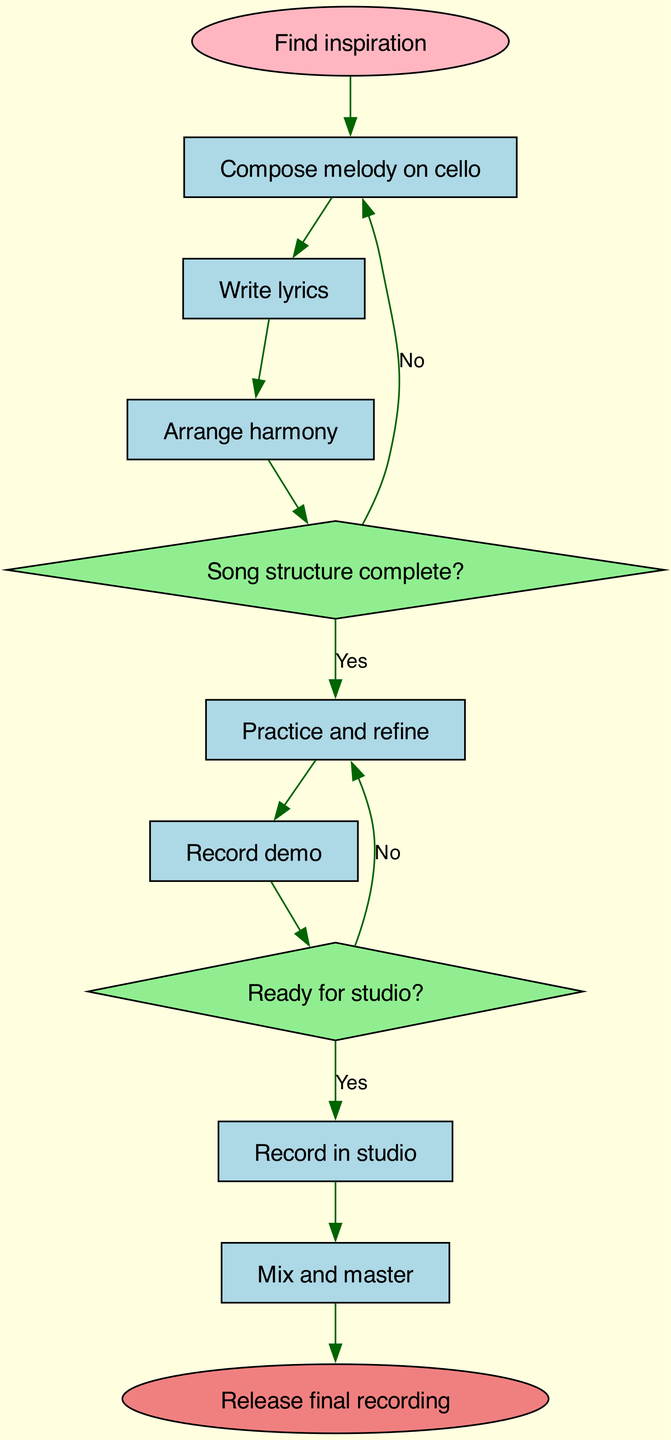What is the first step in the songwriting process? The diagram indicates that the first step is represented by the node labeled "Find inspiration." This is where the process begins, setting the foundation for all subsequent activities in songwriting.
Answer: Find inspiration How many decision points are there in the flowchart? In the diagram, there are two decision points, labeled "Song structure complete?" and "Ready for studio?" Each decision affects the flow of the process based on different criteria.
Answer: 2 What is the output of the final step in the process? The final step in the diagram is labeled "Release final recording." This marks the completion of the entire songwriting process, leading to the release of the finalized song.
Answer: Release final recording If the song structure is not complete, where does the flow lead? According to the diagram, if the song structure is not complete (indicated by the "No" path from the decision point), it leads back to "Compose melody on cello." This means the songwriter needs to revisit the melody creation step before progressing.
Answer: Compose melody on cello What happens after recording the demo? Following the "Record demo" step in the diagram, the next action indicated is "Ready for studio?" This decision point is crucial as it determines whether the process can move forward to the studio recording phase.
Answer: Ready for studio? What does the process require before recording in the studio? The diagram states that before recording in the studio, the song must be deemed "Ready for studio?". This step signifies that the songwriter needs to ensure their song is polished enough for professional recording.
Answer: Ready for studio? If the lyrics are written, what is the next step? Once the "Write lyrics" process is completed, the flowchart indicates that the next activity is "Arrange harmony." This shows how the elements of the song development progress in a sequential manner.
Answer: Arrange harmony What color is used for decision nodes in the diagram? The diagram uses a light green color for decision nodes, which helps differentiate them from other types of nodes such as processes and start/end points. This visual cue aids in quickly identifying decision-making points in the process.
Answer: Light green 